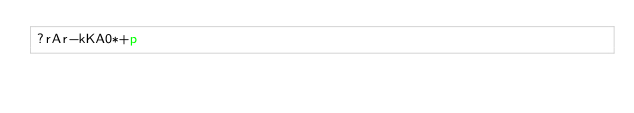Convert code to text. <code><loc_0><loc_0><loc_500><loc_500><_dc_>?rAr-kKA0*+p</code> 